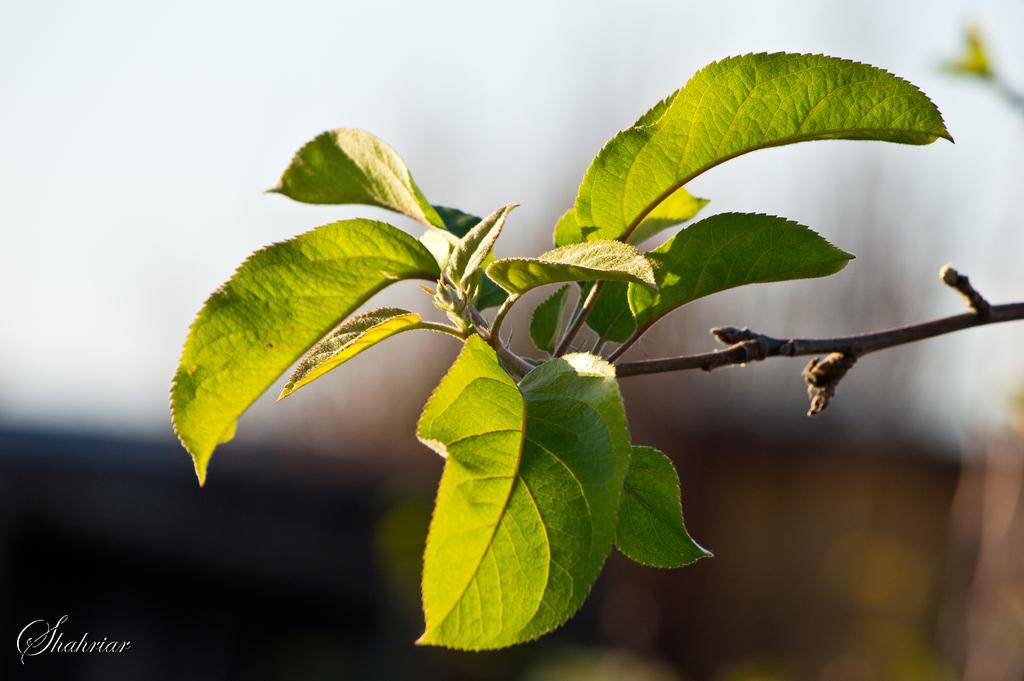What is present in the image? There is a plant in the image. Can you describe the plant's appearance? There are leaves visible in the image. Is there any text or marking in the image? Yes, there is a watermark in the bottom left corner of the image. How would you describe the lighting in the image? The image appears to have a dark or dimly lit appearance. What type of chain can be seen holding the plant in the image? There is no chain present in the image; the plant is not being held by any visible restraints. 